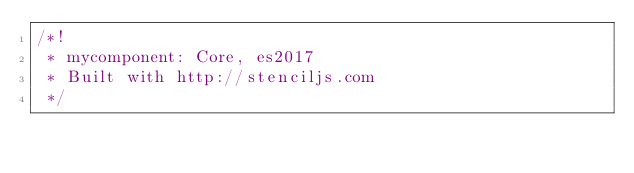Convert code to text. <code><loc_0><loc_0><loc_500><loc_500><_JavaScript_>/*!
 * mycomponent: Core, es2017
 * Built with http://stenciljs.com
 */</code> 